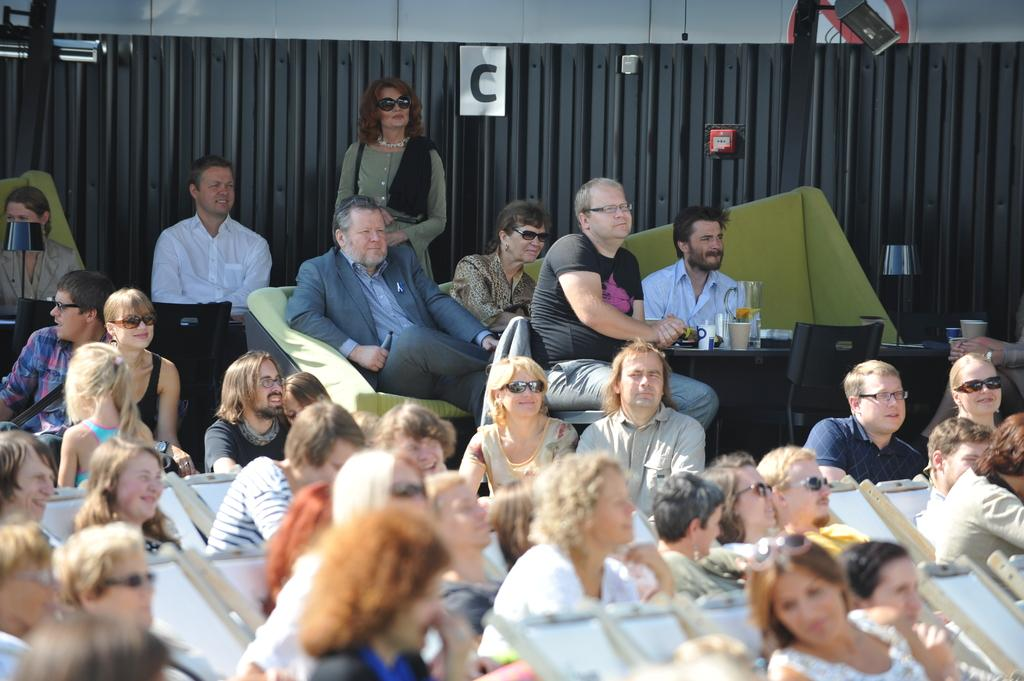What are the people in the image doing? The people in the image are sitting on chairs. What can be seen on the table in the image? There are objects on a table in the image. What is the color scheme of the background in the image? The background of the image is in black and grey color. Can you describe any specific object visible in the image? Yes, there is a glass visible in the image. What type of elbow is being used to stir the love in the dinner scene? There is no elbow, love, or dinner scene present in the image. 